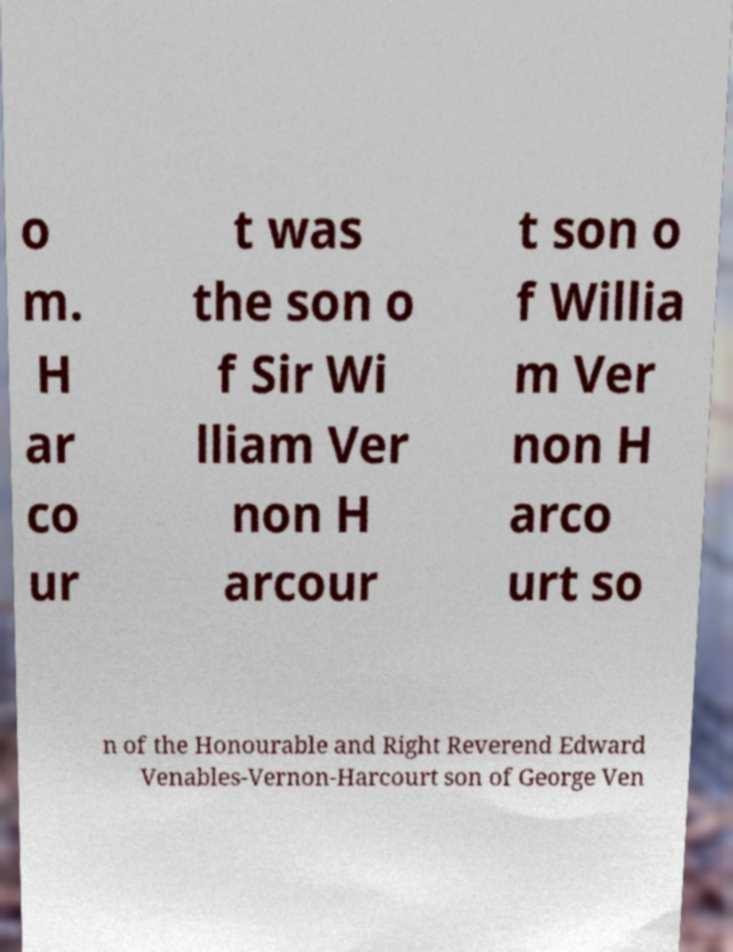Could you extract and type out the text from this image? o m. H ar co ur t was the son o f Sir Wi lliam Ver non H arcour t son o f Willia m Ver non H arco urt so n of the Honourable and Right Reverend Edward Venables-Vernon-Harcourt son of George Ven 